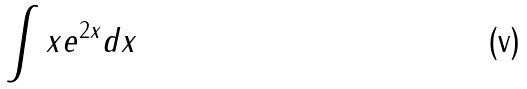Convert formula to latex. <formula><loc_0><loc_0><loc_500><loc_500>\int x e ^ { 2 x } d x</formula> 